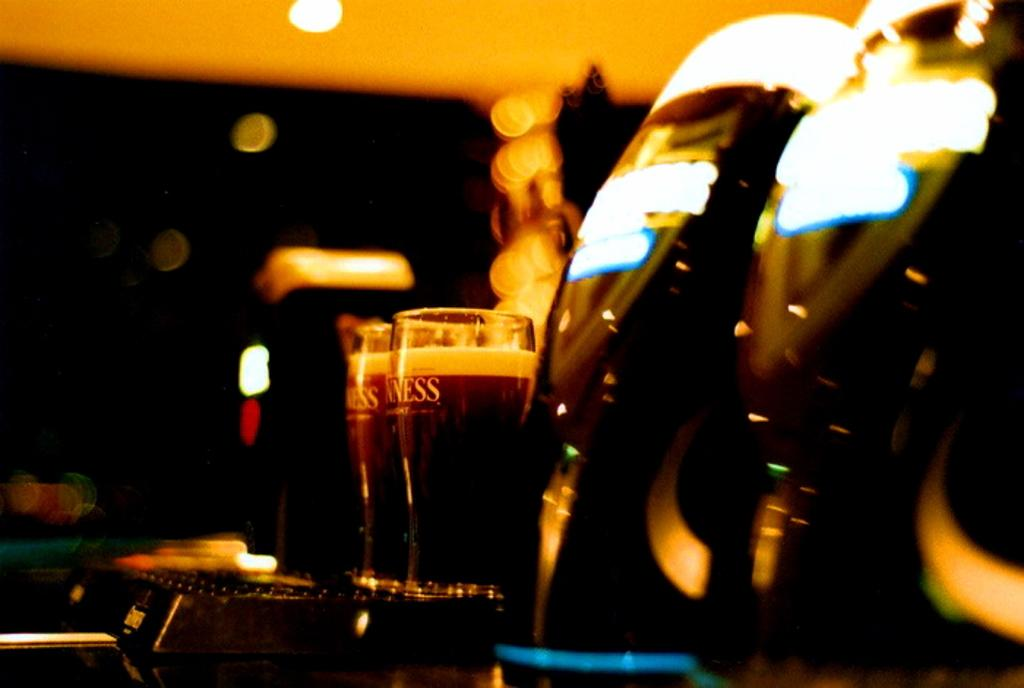What can be seen in the glasses in the image? There are drinks in the two glasses in the image. Where are the glasses placed? The glasses are on a table. Can you describe the background of the image? The background of the image is blurred. What is the source of light in the image? There is a light visible at the top of the image. What color are the objects on the right side of the image? The objects on the right side of the image are black. What type of lead can be seen in the image? There is no lead present in the image. Is there a drawer visible in the image? There is no drawer visible in the image. 